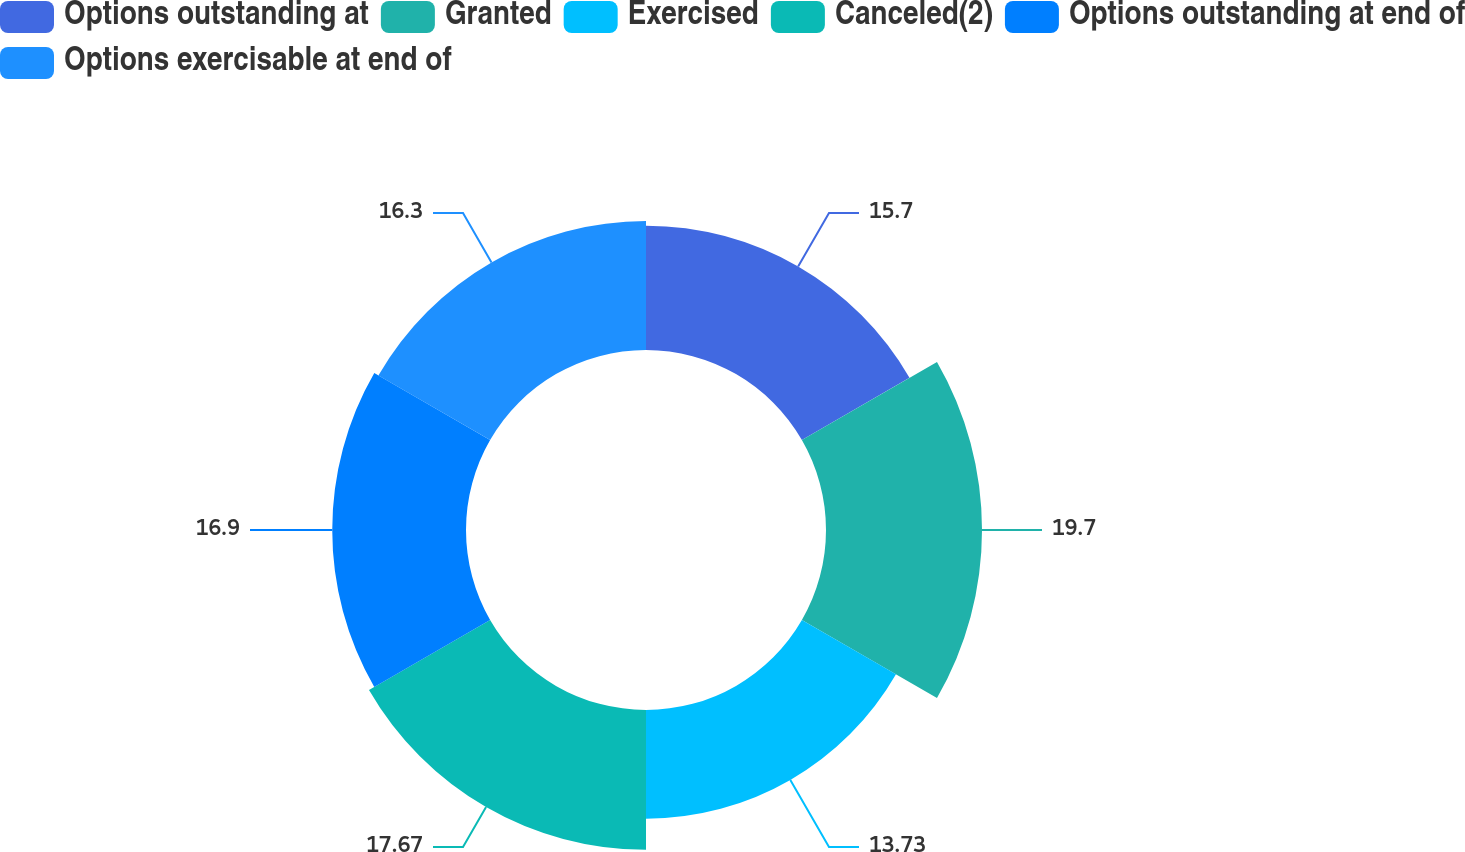<chart> <loc_0><loc_0><loc_500><loc_500><pie_chart><fcel>Options outstanding at<fcel>Granted<fcel>Exercised<fcel>Canceled(2)<fcel>Options outstanding at end of<fcel>Options exercisable at end of<nl><fcel>15.7%<fcel>19.71%<fcel>13.73%<fcel>17.67%<fcel>16.9%<fcel>16.3%<nl></chart> 